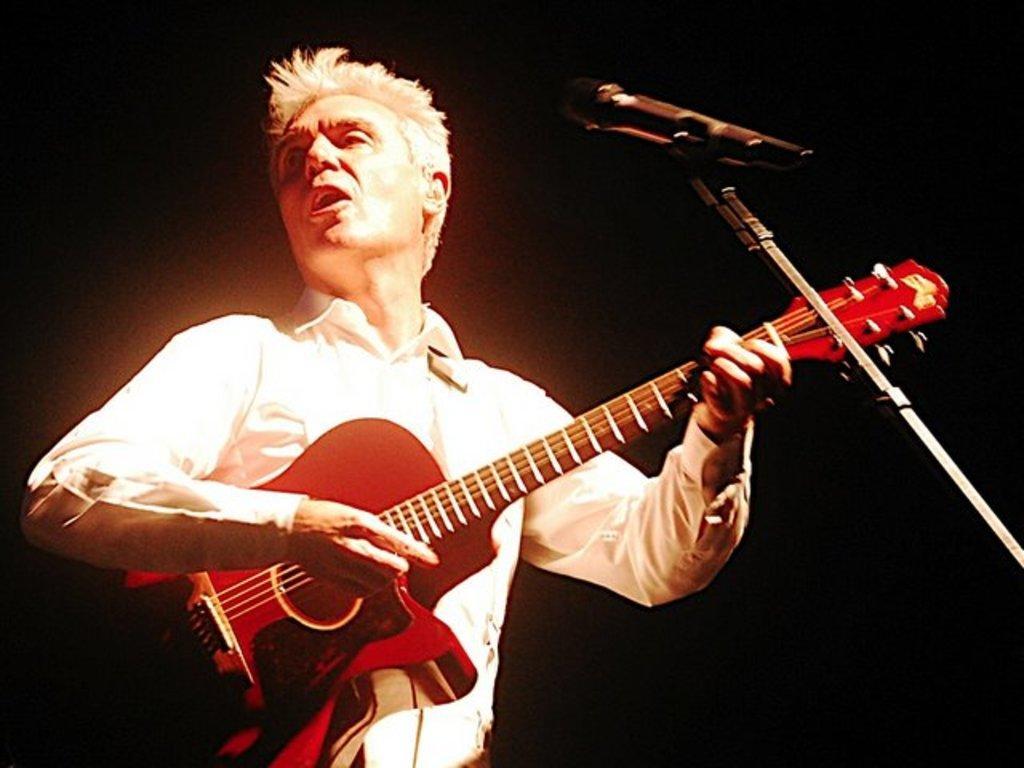How would you summarize this image in a sentence or two? In this image i can see a person holding a guitar and there is a microphone in front of him. 